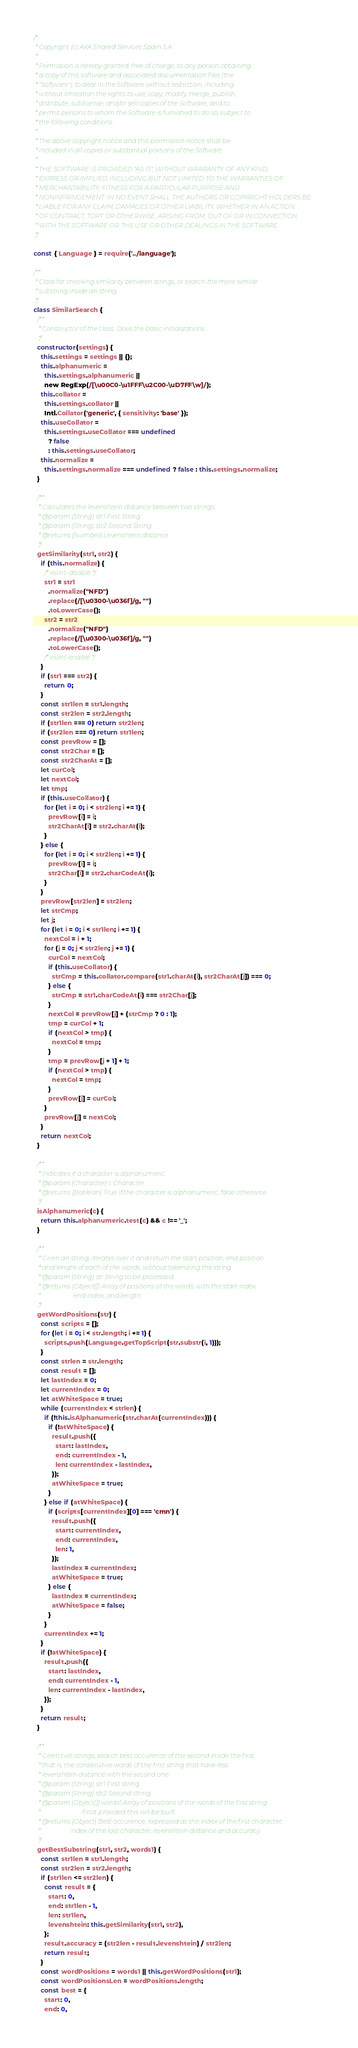<code> <loc_0><loc_0><loc_500><loc_500><_JavaScript_>/*
 * Copyright (c) AXA Shared Services Spain S.A.
 *
 * Permission is hereby granted, free of charge, to any person obtaining
 * a copy of this software and associated documentation files (the
 * "Software"), to deal in the Software without restriction, including
 * without limitation the rights to use, copy, modify, merge, publish,
 * distribute, sublicense, and/or sell copies of the Software, and to
 * permit persons to whom the Software is furnished to do so, subject to
 * the following conditions:
 *
 * The above copyright notice and this permission notice shall be
 * included in all copies or substantial portions of the Software.
 *
 * THE SOFTWARE IS PROVIDED "AS IS", WITHOUT WARRANTY OF ANY KIND,
 * EXPRESS OR IMPLIED, INCLUDING BUT NOT LIMITED TO THE WARRANTIES OF
 * MERCHANTABILITY, FITNESS FOR A PARTICULAR PURPOSE AND
 * NONINFRINGEMENT. IN NO EVENT SHALL THE AUTHORS OR COPYRIGHT HOLDERS BE
 * LIABLE FOR ANY CLAIM, DAMAGES OR OTHER LIABILITY, WHETHER IN AN ACTION
 * OF CONTRACT, TORT OR OTHERWISE, ARISING FROM, OUT OF OR IN CONNECTION
 * WITH THE SOFTWARE OR THE USE OR OTHER DEALINGS IN THE SOFTWARE.
 */

const { Language } = require('../language');

/**
 * Class for checking similarity between strings, or search the more similar
 * substring inside an string.
 */
class SimilarSearch {
  /**
   * Constructor of the class. Does the basic initializations.
   */
  constructor(settings) {
    this.settings = settings || {};
    this.alphanumeric =
      this.settings.alphanumeric ||
      new RegExp(/[\u00C0-\u1FFF\u2C00-\uD7FF\w]/);
    this.collator =
      this.settings.collator ||
      Intl.Collator('generic', { sensitivity: 'base' });
    this.useCollator =
      this.settings.useCollator === undefined
        ? false
        : this.settings.useCollator;
    this.normalize =
      this.settings.normalize === undefined ? false : this.settings.normalize;
  }

  /**
   * Calculates the levenshtein distance between two strings.
   * @param {String} str1 First String.
   * @param {String} str2 Second String.
   * @returns {Number} Levenshtein distance.
   */
  getSimilarity(str1, str2) {
    if (this.normalize) {
      /* eslint-disable */
      str1 = str1
        .normalize("NFD")
        .replace(/[\u0300-\u036f]/g, "")
        .toLowerCase();
      str2 = str2
        .normalize("NFD")
        .replace(/[\u0300-\u036f]/g, "")
        .toLowerCase();
      /* eslint-enable */
    }
    if (str1 === str2) {
      return 0;
    }
    const str1len = str1.length;
    const str2len = str2.length;
    if (str1len === 0) return str2len;
    if (str2len === 0) return str1len;
    const prevRow = [];
    const str2Char = [];
    const str2CharAt = [];
    let curCol;
    let nextCol;
    let tmp;
    if (this.useCollator) {
      for (let i = 0; i < str2len; i += 1) {
        prevRow[i] = i;
        str2CharAt[i] = str2.charAt(i);
      }
    } else {
      for (let i = 0; i < str2len; i += 1) {
        prevRow[i] = i;
        str2Char[i] = str2.charCodeAt(i);
      }
    }
    prevRow[str2len] = str2len;
    let strCmp;
    let j;
    for (let i = 0; i < str1len; i += 1) {
      nextCol = i + 1;
      for (j = 0; j < str2len; j += 1) {
        curCol = nextCol;
        if (this.useCollator) {
          strCmp = this.collator.compare(str1.charAt(i), str2CharAt[j]) === 0;
        } else {
          strCmp = str1.charCodeAt(i) === str2Char[j];
        }
        nextCol = prevRow[j] + (strCmp ? 0 : 1);
        tmp = curCol + 1;
        if (nextCol > tmp) {
          nextCol = tmp;
        }
        tmp = prevRow[j + 1] + 1;
        if (nextCol > tmp) {
          nextCol = tmp;
        }
        prevRow[j] = curCol;
      }
      prevRow[j] = nextCol;
    }
    return nextCol;
  }

  /**
   * Indicates if a character is alphanumeric.
   * @param {Character} c Character.
   * @returns {Boolean} True if the character is alphanumeric, false otherwise.
   */
  isAlphanumeric(c) {
    return this.alphanumeric.test(c) && c !== '_';
  }

  /**
   * Given an string, iterates over it and return the start position, end position
   * and length of each of the words, without tokenizing the string.
   * @param {String} str String to be processed.
   * @returns {Object[]} Array of positions of the words, with the start index,
   *                     end index, and length.
   */
  getWordPositions(str) {
    const scripts = [];
    for (let i = 0; i < str.length; i += 1) {
      scripts.push(Language.getTopScript(str.substr(i, 1)));
    }
    const strlen = str.length;
    const result = [];
    let lastIndex = 0;
    let currentIndex = 0;
    let atWhiteSpace = true;
    while (currentIndex < strlen) {
      if (!this.isAlphanumeric(str.charAt(currentIndex))) {
        if (!atWhiteSpace) {
          result.push({
            start: lastIndex,
            end: currentIndex - 1,
            len: currentIndex - lastIndex,
          });
          atWhiteSpace = true;
        }
      } else if (atWhiteSpace) {
        if (scripts[currentIndex][0] === 'cmn') {
          result.push({
            start: currentIndex,
            end: currentIndex,
            len: 1,
          });
          lastIndex = currentIndex;
          atWhiteSpace = true;
        } else {
          lastIndex = currentIndex;
          atWhiteSpace = false;
        }
      }
      currentIndex += 1;
    }
    if (!atWhiteSpace) {
      result.push({
        start: lastIndex,
        end: currentIndex - 1,
        len: currentIndex - lastIndex,
      });
    }
    return result;
  }

  /**
   * Given two strings, search best occurence of the second inside the first,
   * that is, the consecutive words of the first string that have less
   * levenshtein distance with the second one.
   * @param {String} str1 First string.
   * @param {String} str2 Second string.
   * @param {Object[]} words1 Array of positions of the words of the first string.
   *                          If not provided this will be built.
   * @returns {Object} Best occurence, expressed as the index of the first character,
   *                   index of the last character, levenshtein distance and accuracy.
   */
  getBestSubstring(str1, str2, words1) {
    const str1len = str1.length;
    const str2len = str2.length;
    if (str1len <= str2len) {
      const result = {
        start: 0,
        end: str1len - 1,
        len: str1len,
        levenshtein: this.getSimilarity(str1, str2),
      };
      result.accuracy = (str2len - result.levenshtein) / str2len;
      return result;
    }
    const wordPositions = words1 || this.getWordPositions(str1);
    const wordPositionsLen = wordPositions.length;
    const best = {
      start: 0,
      end: 0,</code> 